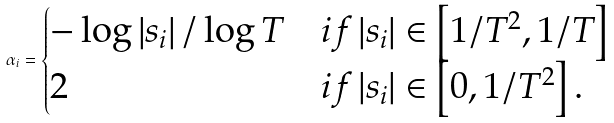<formula> <loc_0><loc_0><loc_500><loc_500>\alpha _ { i } = \begin{cases} - \log \left | s _ { i } \right | / \log T & i f \left | s _ { i } \right | \in \left [ 1 / T ^ { 2 } , 1 / T \right ] \\ 2 & i f \left | s _ { i } \right | \in \left [ 0 , 1 / T ^ { 2 } \right ] . \end{cases}</formula> 